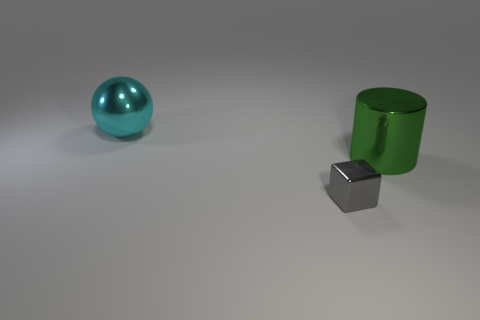Can you tell if these objects are real or computer-generated? The objects have a distinct, perfect quality and the lighting is very uniform, which are often indicators of computer-generated imagery. Real objects typically show some imperfections or variations in texture and lighting, which are not present here. This suggests the image is likely a digital rendering. 